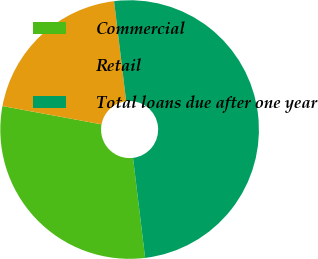<chart> <loc_0><loc_0><loc_500><loc_500><pie_chart><fcel>Commercial<fcel>Retail<fcel>Total loans due after one year<nl><fcel>29.82%<fcel>20.18%<fcel>50.0%<nl></chart> 